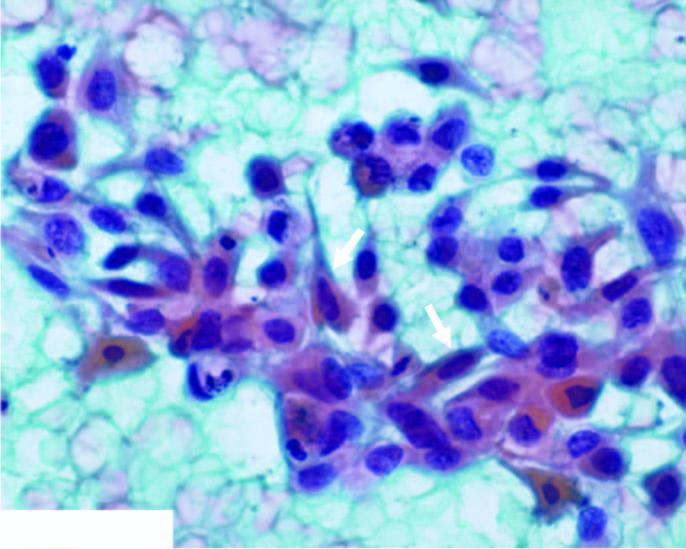re a few fibre cells and caudate cells also seen?
Answer the question using a single word or phrase. Yes 